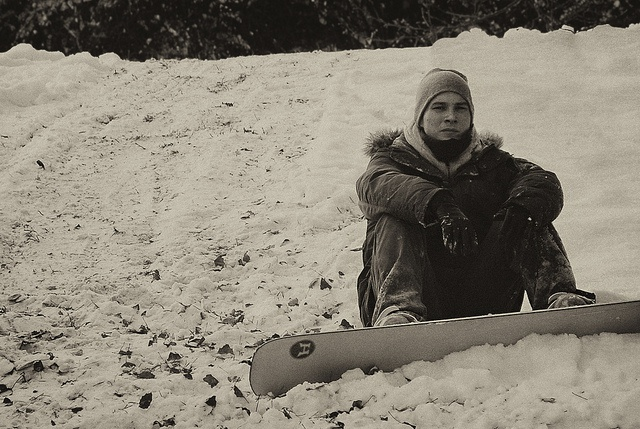Describe the objects in this image and their specific colors. I can see people in black, gray, and darkgray tones and snowboard in black and gray tones in this image. 